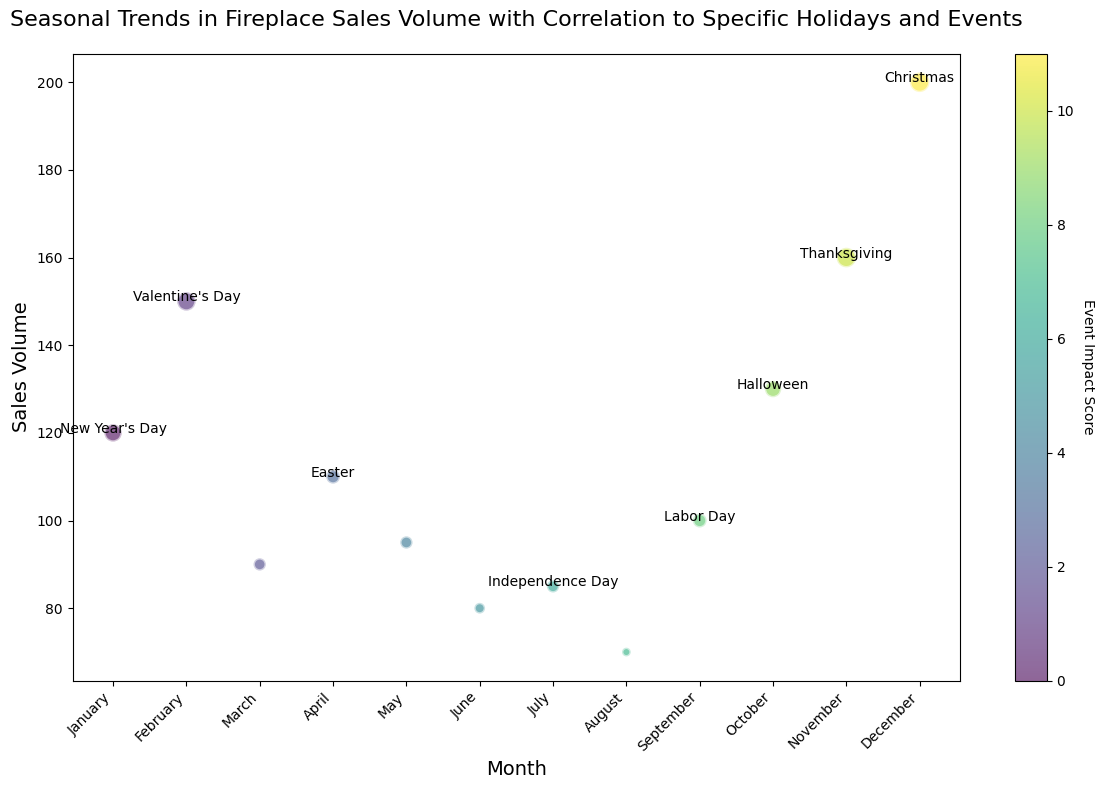Which month has the highest sales volume? By looking at the vertical position of the bubbles, we can see that the bubble for December is the highest, indicating it has the highest sales volume.
Answer: December What is the event impact score for Halloween? Look for the bubble labeled "Halloween" and check its color or size to determine the impact score. The size of the bubble corresponds to an impact score of 7.
Answer: 7 How does the sales volume in March compare to August? Compare the vertical positions of the bubbles for March and August. March's bubble is higher, indicating it has a greater sales volume than August.
Answer: March has higher sales Which event has the largest impact score and what is the corresponding sales volume? Look for the bubble that is the largest in size. The largest bubbles are for Thanksgiving and Christmas, both with an impact score of 10. The corresponding sales volumes are 160 for Thanksgiving and 200 for Christmas.
Answer: Christmas has the largest impact score with a sales volume of 200 Calculate the average sales volume for the months with no events. The months with no events are March, May, June, and August. Their sales volumes are 90, 95, 80, and 70, respectively. Sum these volumes (90 + 95 + 80 + 70 = 335) and divide by the number of months (4) to get the average.
Answer: 83.75 Which holiday has a greater impact on sales, Labor Day or Independence Day? Compare the sizes of the bubbles labeled "Labor Day" and "Independence Day." Labor Day has a larger bubble indicating a higher event impact score of 5 compared to Independence Day's 4.
Answer: Labor Day What is the difference in sales volume between Valentine’s Day and Easter? Look at the vertical positions of the bubbles for Valentine’s Day and Easter. Valentine’s Day has a sales volume of 150, and Easter has 110. Subtract Easter’s sales volume from Valentine’s Day’s (150 - 110).
Answer: 40 Which month shows a sales volume significantly influenced by an event but has a relatively low event impact score? Identify the month with an event label that has a relatively smaller bubble compared to others with higher sizes. Easter in April fits this description with an impact score of 5.
Answer: April (Easter) How many holidays have an event impact score greater than 8? Count the number of bubbles with event labels that are large in size corresponding to impact scores greater than 8. The holidays are New Year's Day, Valentine’s Day, Thanksgiving, and Christmas.
Answer: 4 What is the trend in sales volume from January to June? Look at the vertical positions of the bubbles from January to June. The sales volume starts high in January, increases in February, then generally decreases from March to June.
Answer: Decreasing trend 